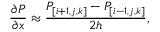<formula> <loc_0><loc_0><loc_500><loc_500>\frac { \partial P } { \partial x } \approx \frac { P _ { [ i + 1 , j , k ] } - P _ { [ i - 1 , j , k ] } } { 2 h } ,</formula> 